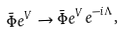Convert formula to latex. <formula><loc_0><loc_0><loc_500><loc_500>\bar { \Phi } e ^ { V } \rightarrow \bar { \Phi } e ^ { V } e ^ { - i \Lambda } ,</formula> 